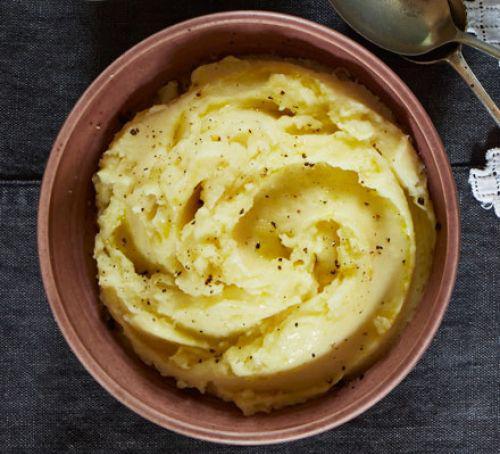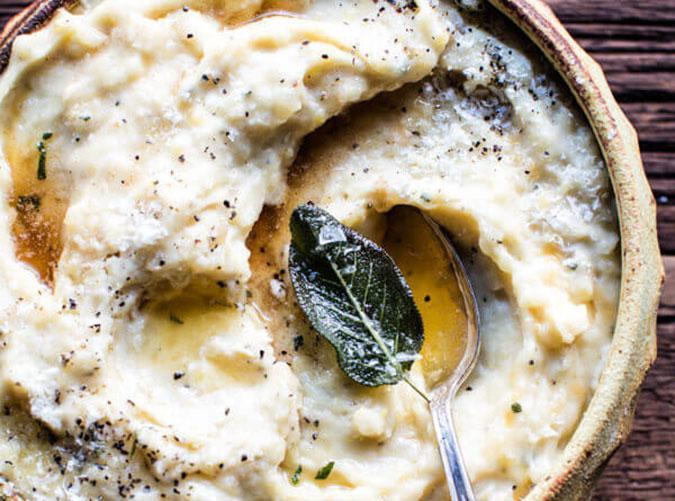The first image is the image on the left, the second image is the image on the right. Assess this claim about the two images: "The dish in the image on the left has a spoon in it.". Correct or not? Answer yes or no. No. The first image is the image on the left, the second image is the image on the right. Examine the images to the left and right. Is the description "Each image shows a spoon with a bowl of mashed potatoes, and the spoons are made of the same type of material." accurate? Answer yes or no. No. 